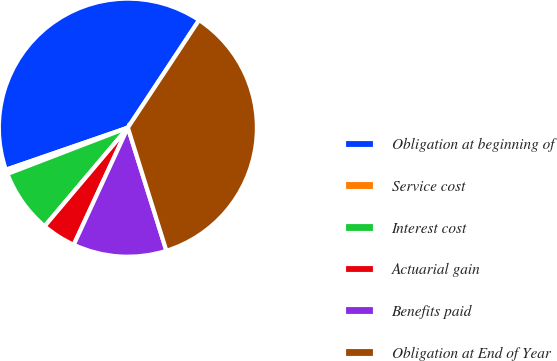Convert chart to OTSL. <chart><loc_0><loc_0><loc_500><loc_500><pie_chart><fcel>Obligation at beginning of<fcel>Service cost<fcel>Interest cost<fcel>Actuarial gain<fcel>Benefits paid<fcel>Obligation at End of Year<nl><fcel>39.59%<fcel>0.55%<fcel>8.0%<fcel>4.27%<fcel>11.72%<fcel>35.87%<nl></chart> 